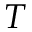Convert formula to latex. <formula><loc_0><loc_0><loc_500><loc_500>T</formula> 